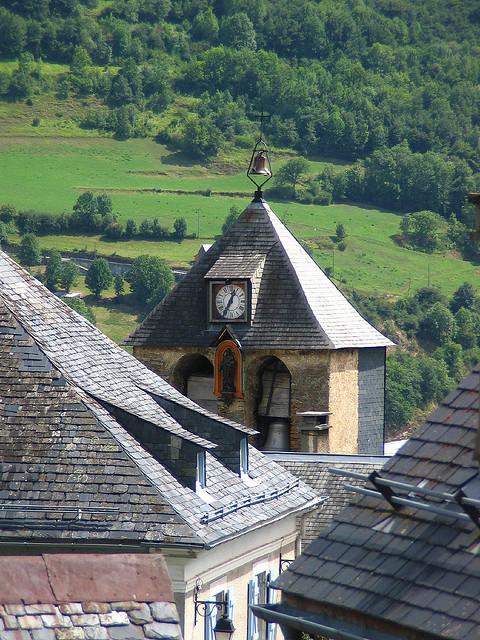What time does the clock say?
Concise answer only. 12:35. Is this a modern city?
Write a very short answer. No. Where is the bell?
Be succinct. Top of tower. 